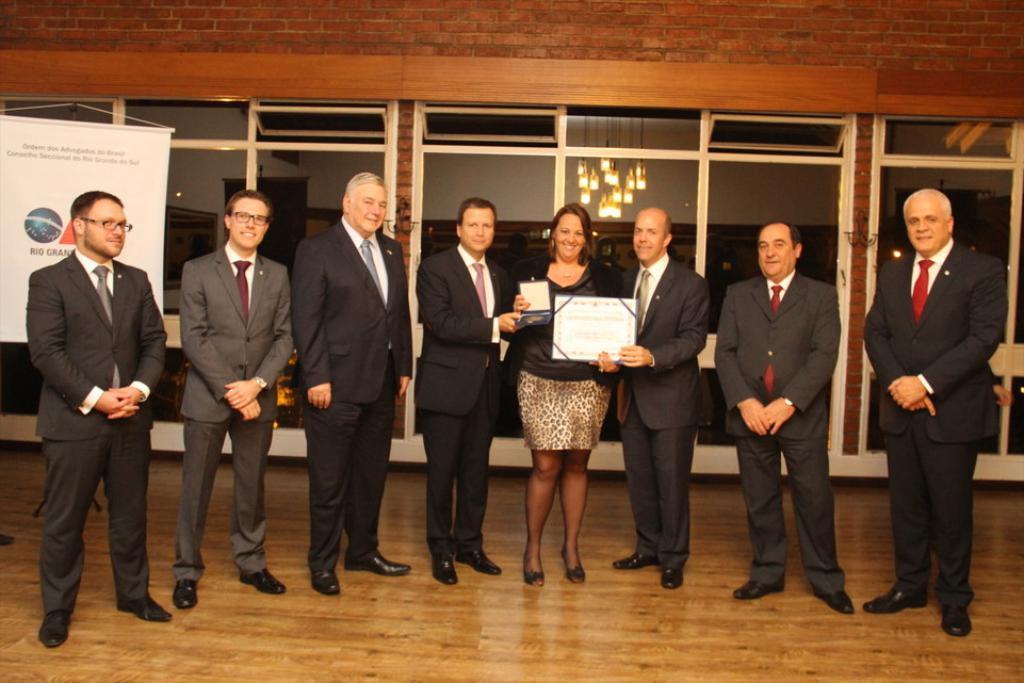Can you describe this image briefly? This image is taken indoors. At the bottom of the image there is a floor. At the top of the image there is a wall. In the background there are a few glass doors and there is a board with a text on it. In the middle of the image seven men and a woman are standing on the floor. They are with smiling faces. Two men and a woman are holding two objects in their hands. 